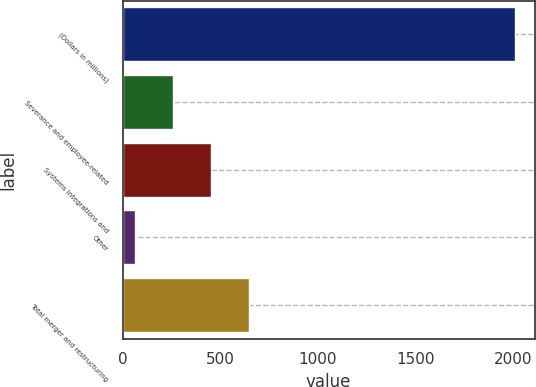Convert chart to OTSL. <chart><loc_0><loc_0><loc_500><loc_500><bar_chart><fcel>(Dollars in millions)<fcel>Severance and employee-related<fcel>Systems integrations and<fcel>Other<fcel>Total merger and restructuring<nl><fcel>2007<fcel>258.3<fcel>452.6<fcel>64<fcel>646.9<nl></chart> 